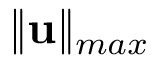Convert formula to latex. <formula><loc_0><loc_0><loc_500><loc_500>\| u \| _ { \max }</formula> 